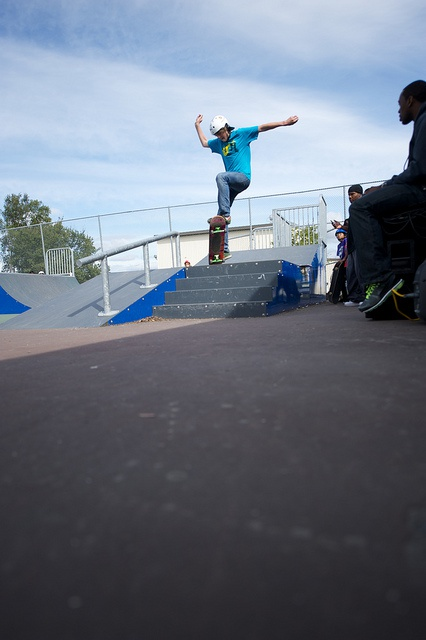Describe the objects in this image and their specific colors. I can see people in gray, black, and lavender tones, people in gray, lavender, lightblue, black, and teal tones, people in gray, black, navy, and maroon tones, skateboard in gray, black, maroon, and brown tones, and people in gray, black, and maroon tones in this image. 